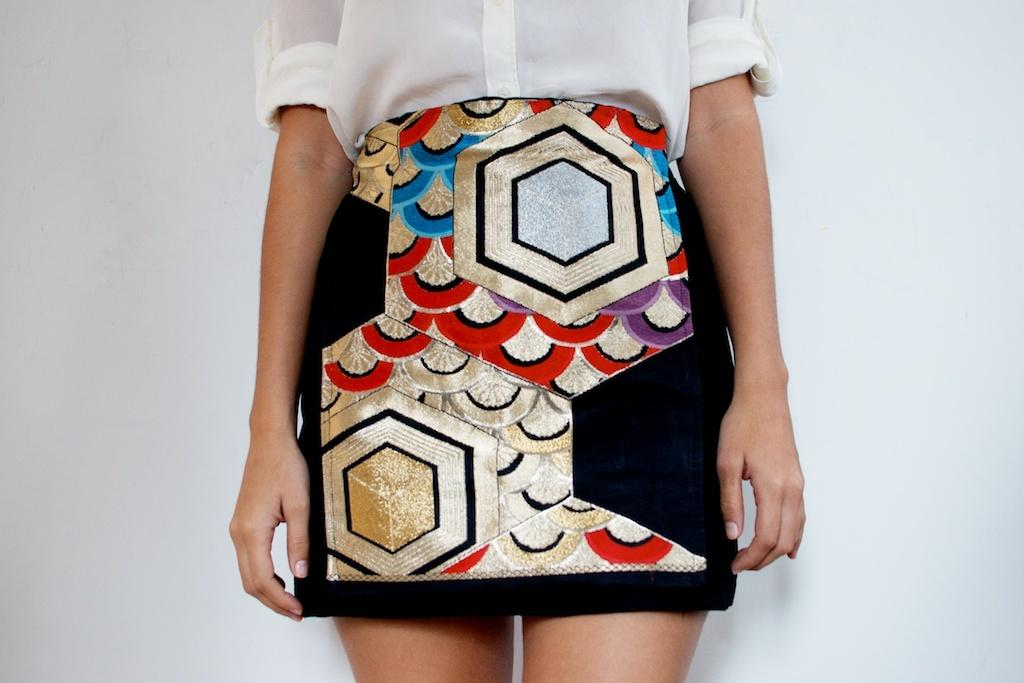What is the main subject of the image? There is a person standing in the center of the image. What is the person wearing? The person is wearing a shirt and a skirt. What can be seen in the background of the image? There is a wall visible in the background of the image. What type of fact can be seen in the image? There is no fact present in the image; it features a person standing in the center, wearing a shirt and a skirt, with a wall visible in the background. Can you tell me how many aunts are in the image? There are no aunts present in the image. 